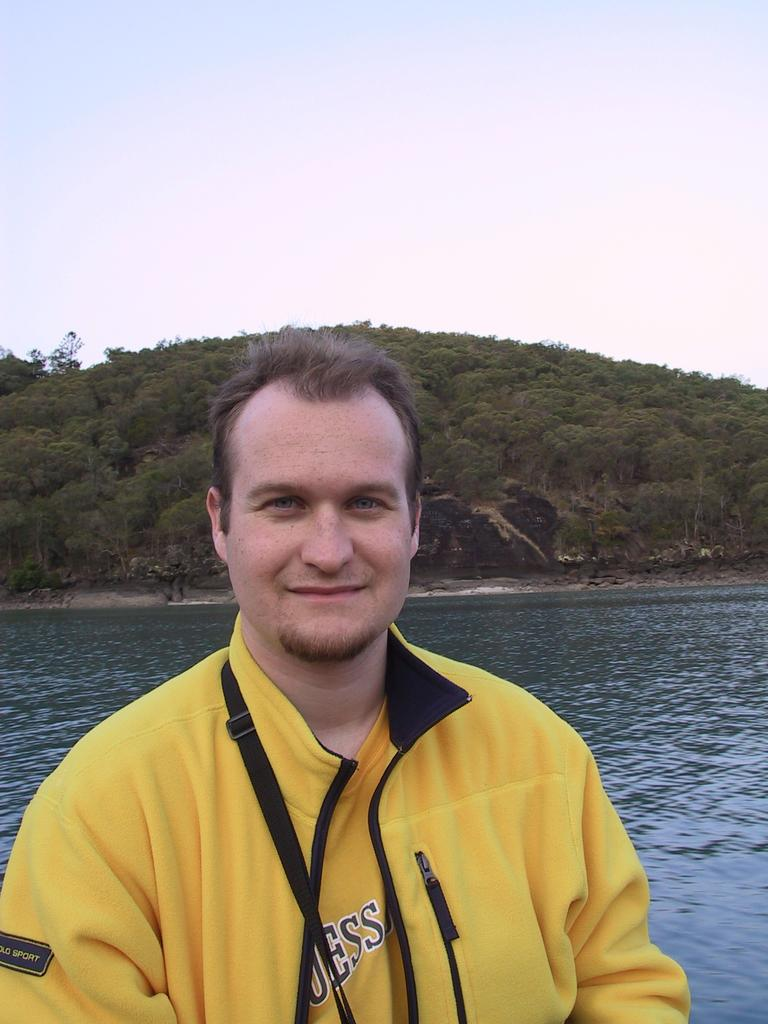<image>
Render a clear and concise summary of the photo. A man stands in front of water wearing a yellow shirt with letters, "ESS" on the front. 